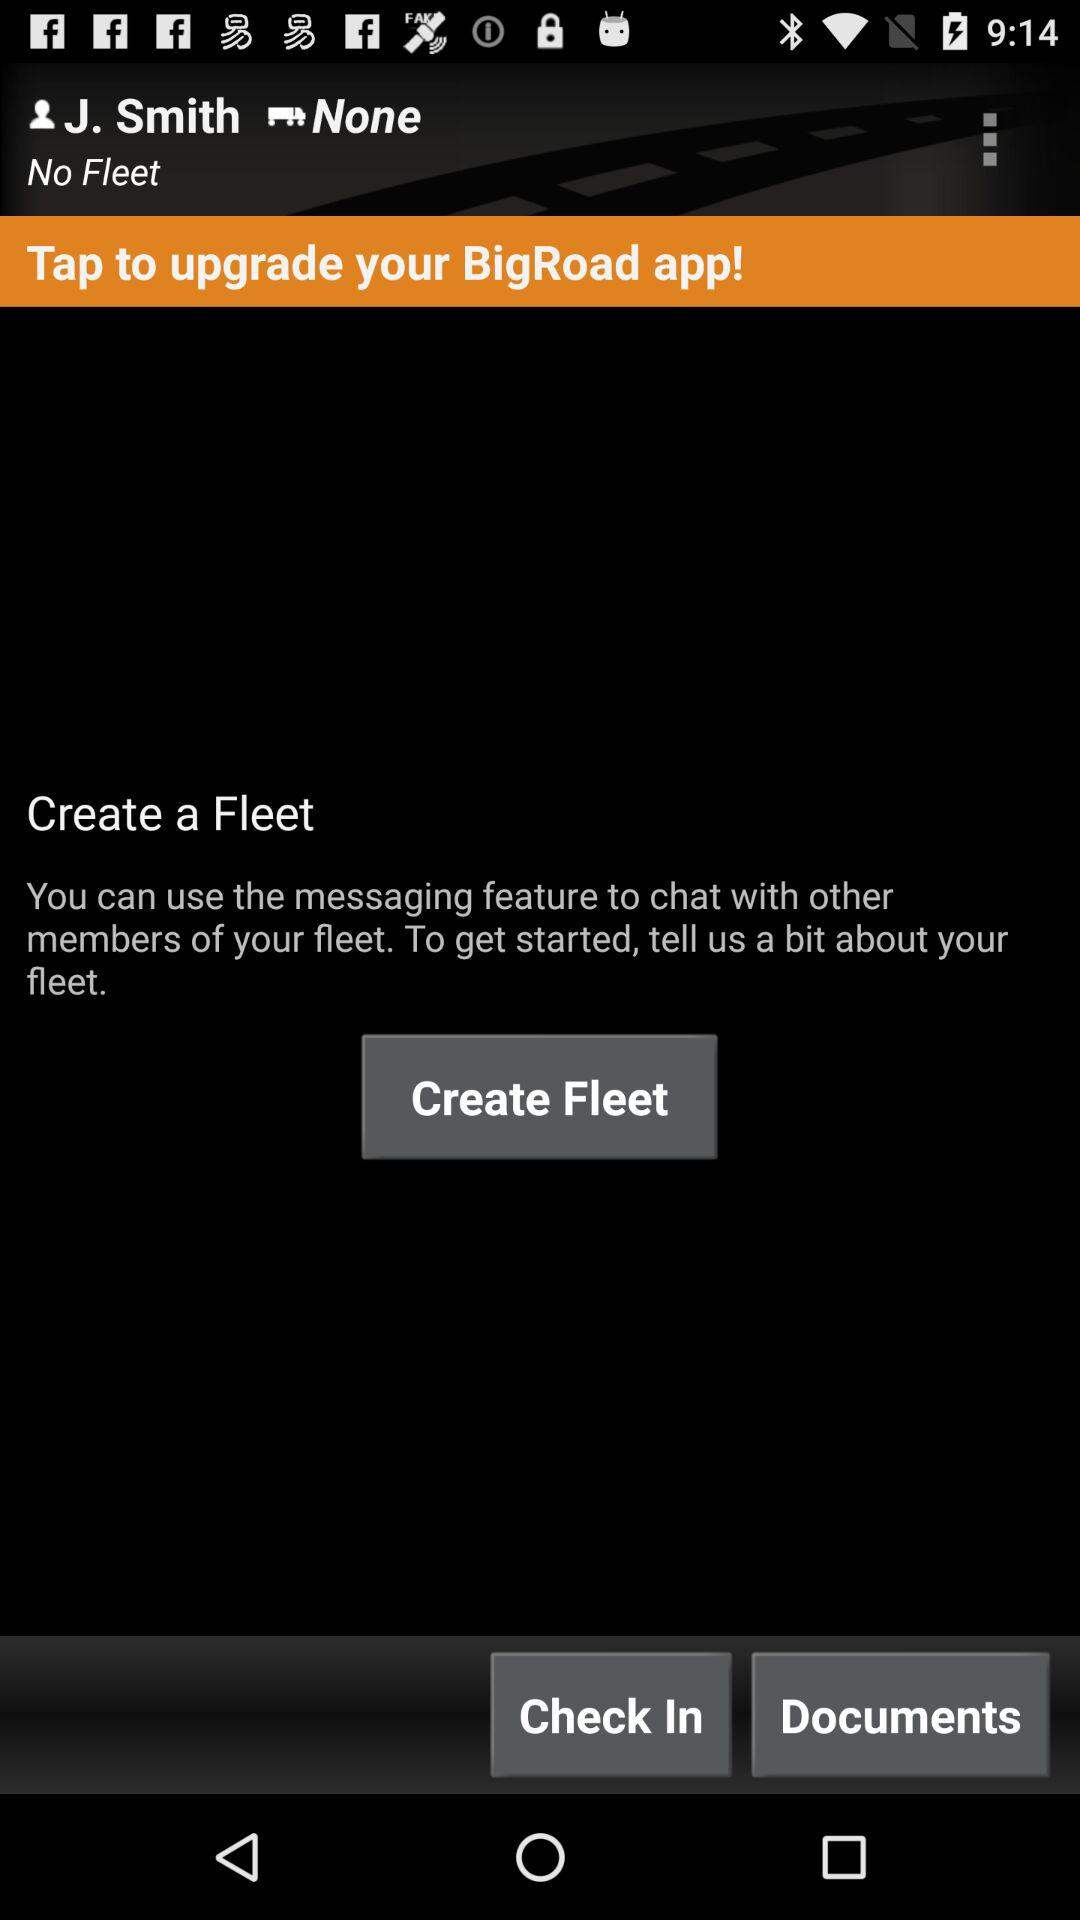Is there any fleet available? There is no fleet available. 